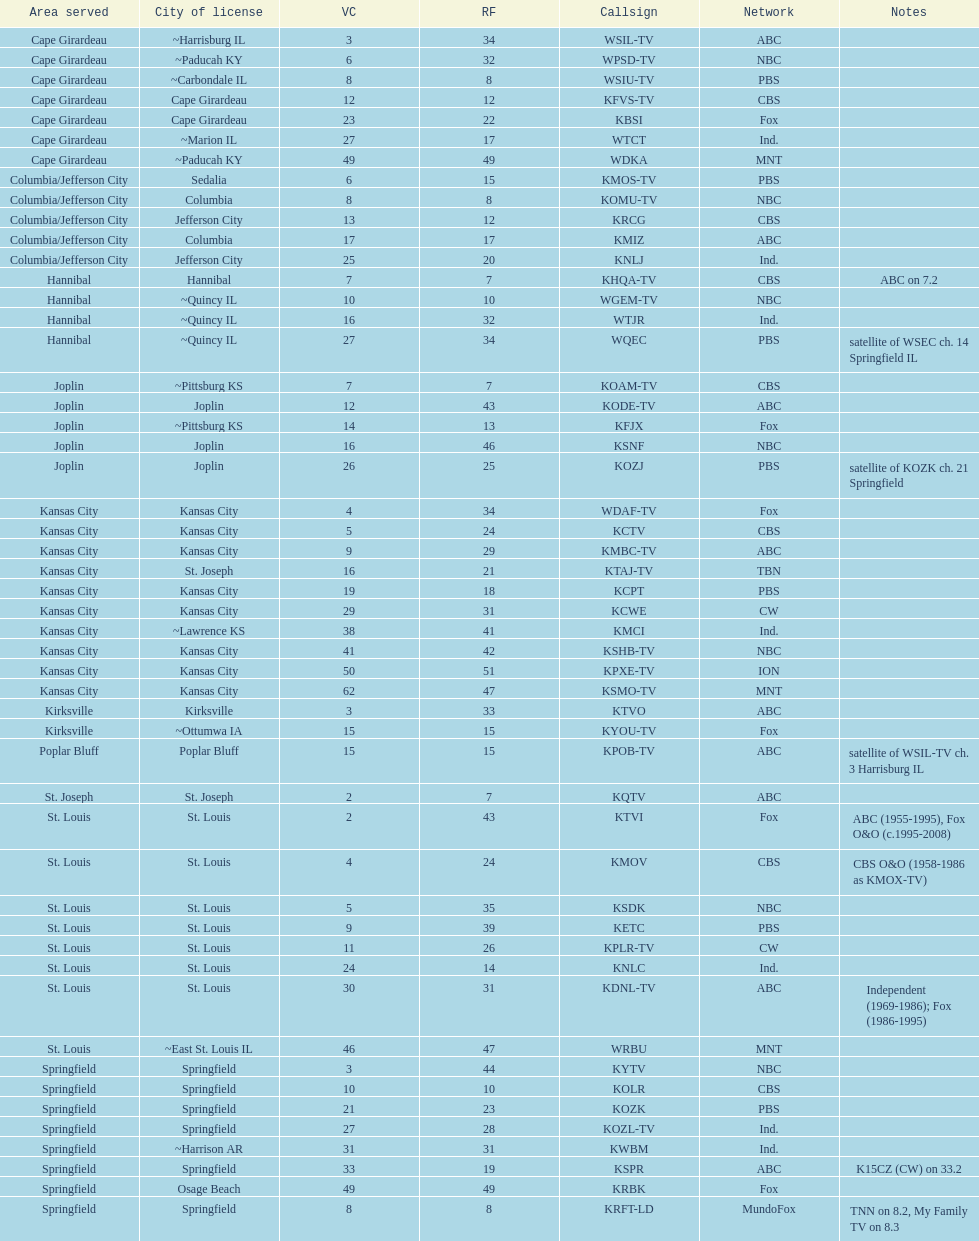How many locations have five or more stations present? 6. 